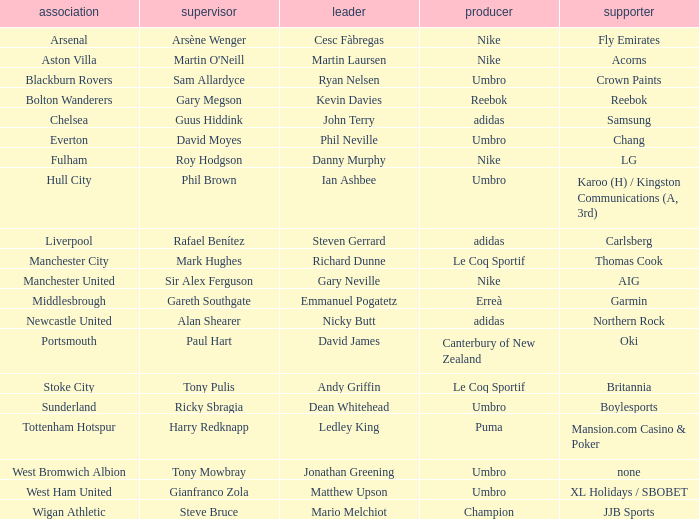Which Manchester United captain is sponsored by Nike? Gary Neville. 